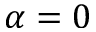Convert formula to latex. <formula><loc_0><loc_0><loc_500><loc_500>\alpha = 0</formula> 